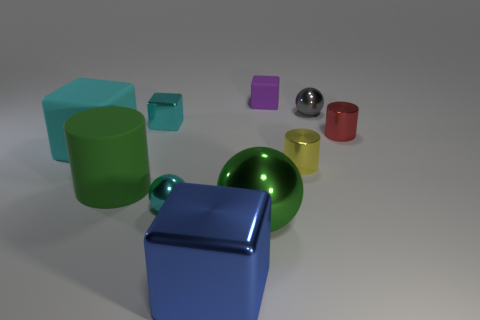What is the shape of the big cyan matte thing?
Offer a very short reply. Cube. There is a large cube that is in front of the tiny metal sphere that is in front of the small block in front of the tiny purple object; what is its material?
Your response must be concise. Metal. What number of other objects are the same material as the gray object?
Provide a succinct answer. 6. How many green things are on the left side of the cyan block behind the tiny red metal cylinder?
Make the answer very short. 1. What number of spheres are either tiny objects or big green matte things?
Provide a short and direct response. 2. There is a cylinder that is both in front of the big matte cube and to the right of the big green metal ball; what is its color?
Provide a succinct answer. Yellow. Are there any other things that are the same color as the tiny metal cube?
Ensure brevity in your answer.  Yes. What is the color of the shiny thing right of the metallic ball that is right of the tiny yellow thing?
Make the answer very short. Red. Do the green cylinder and the green sphere have the same size?
Your answer should be compact. Yes. Are the tiny cyan thing behind the yellow metal cylinder and the tiny cube to the right of the large blue object made of the same material?
Your answer should be compact. No. 